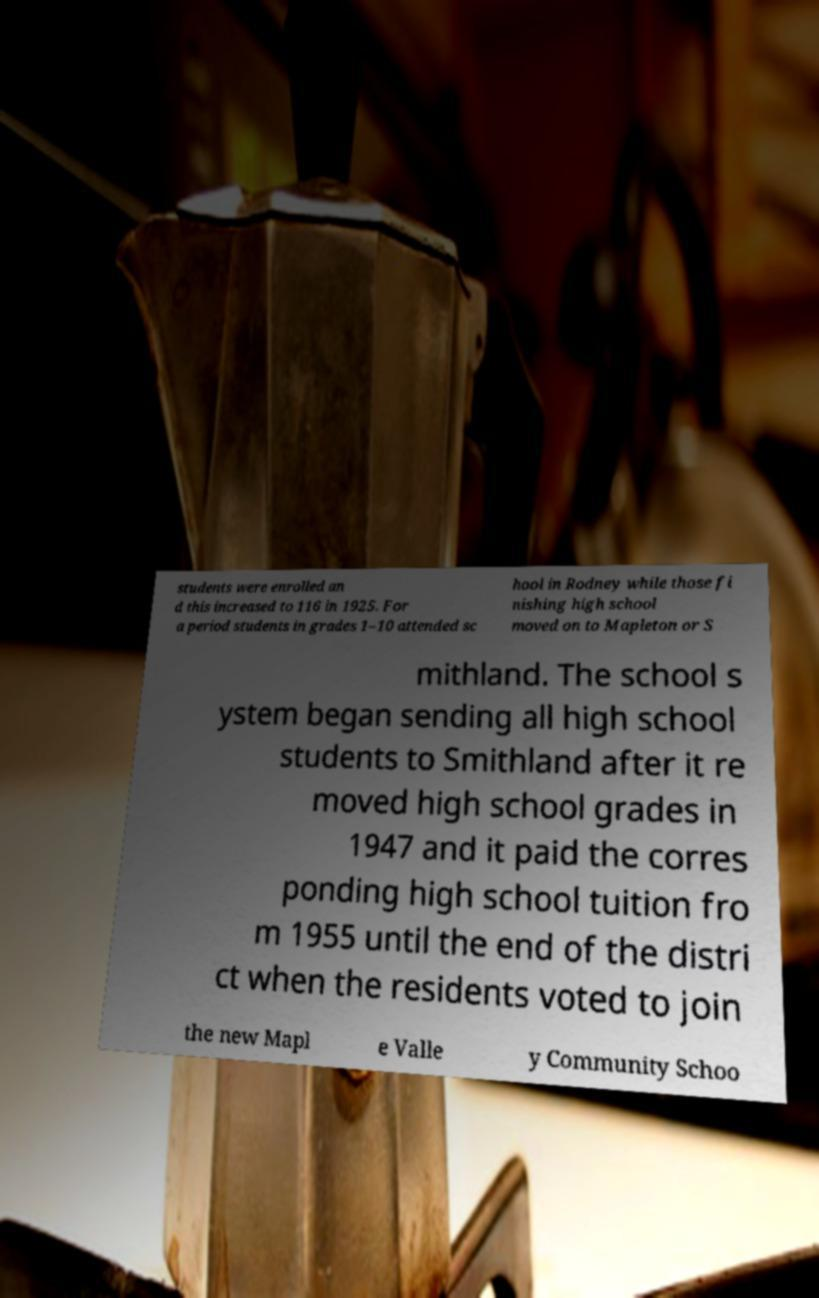Please read and relay the text visible in this image. What does it say? students were enrolled an d this increased to 116 in 1925. For a period students in grades 1–10 attended sc hool in Rodney while those fi nishing high school moved on to Mapleton or S mithland. The school s ystem began sending all high school students to Smithland after it re moved high school grades in 1947 and it paid the corres ponding high school tuition fro m 1955 until the end of the distri ct when the residents voted to join the new Mapl e Valle y Community Schoo 